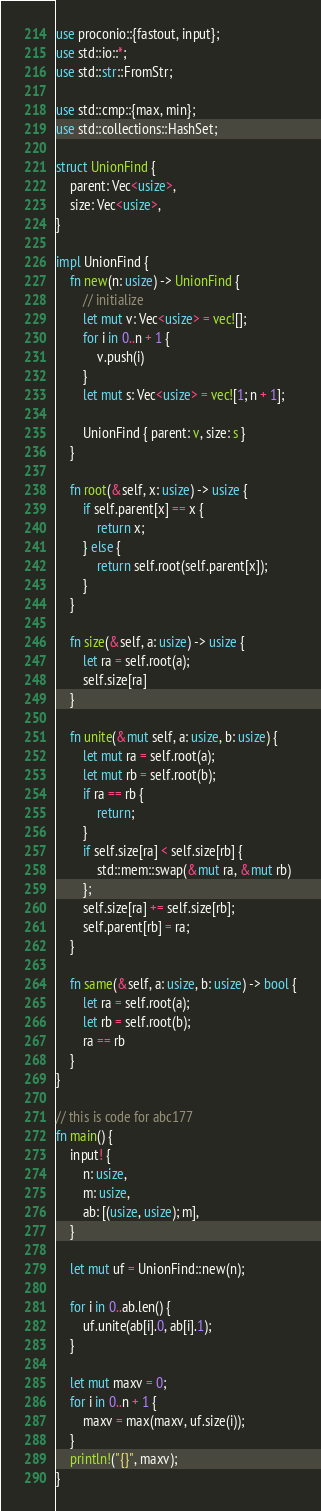Convert code to text. <code><loc_0><loc_0><loc_500><loc_500><_Rust_>use proconio::{fastout, input};
use std::io::*;
use std::str::FromStr;

use std::cmp::{max, min};
use std::collections::HashSet;

struct UnionFind {
    parent: Vec<usize>,
    size: Vec<usize>,
}

impl UnionFind {
    fn new(n: usize) -> UnionFind {
        // initialize
        let mut v: Vec<usize> = vec![];
        for i in 0..n + 1 {
            v.push(i)
        }
        let mut s: Vec<usize> = vec![1; n + 1];

        UnionFind { parent: v, size: s }
    }

    fn root(&self, x: usize) -> usize {
        if self.parent[x] == x {
            return x;
        } else {
            return self.root(self.parent[x]);
        }
    }

    fn size(&self, a: usize) -> usize {
        let ra = self.root(a);
        self.size[ra]
    }

    fn unite(&mut self, a: usize, b: usize) {
        let mut ra = self.root(a);
        let mut rb = self.root(b);
        if ra == rb {
            return;
        }
        if self.size[ra] < self.size[rb] {
            std::mem::swap(&mut ra, &mut rb)
        };
        self.size[ra] += self.size[rb];
        self.parent[rb] = ra;
    }

    fn same(&self, a: usize, b: usize) -> bool {
        let ra = self.root(a);
        let rb = self.root(b);
        ra == rb
    }
}

// this is code for abc177
fn main() {
    input! {
        n: usize,
        m: usize,
        ab: [(usize, usize); m],
    }

    let mut uf = UnionFind::new(n);

    for i in 0..ab.len() {
        uf.unite(ab[i].0, ab[i].1);
    }

    let mut maxv = 0;
    for i in 0..n + 1 {
        maxv = max(maxv, uf.size(i));
    }
    println!("{}", maxv);
}
</code> 